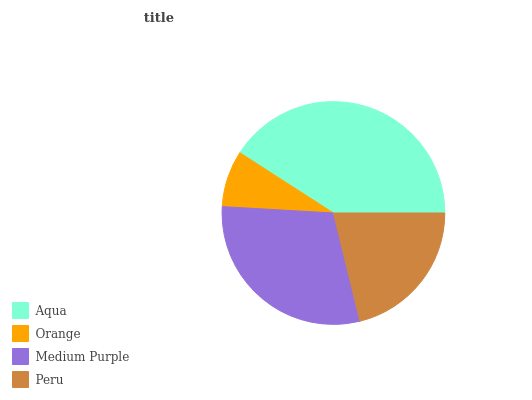Is Orange the minimum?
Answer yes or no. Yes. Is Aqua the maximum?
Answer yes or no. Yes. Is Medium Purple the minimum?
Answer yes or no. No. Is Medium Purple the maximum?
Answer yes or no. No. Is Medium Purple greater than Orange?
Answer yes or no. Yes. Is Orange less than Medium Purple?
Answer yes or no. Yes. Is Orange greater than Medium Purple?
Answer yes or no. No. Is Medium Purple less than Orange?
Answer yes or no. No. Is Medium Purple the high median?
Answer yes or no. Yes. Is Peru the low median?
Answer yes or no. Yes. Is Orange the high median?
Answer yes or no. No. Is Medium Purple the low median?
Answer yes or no. No. 